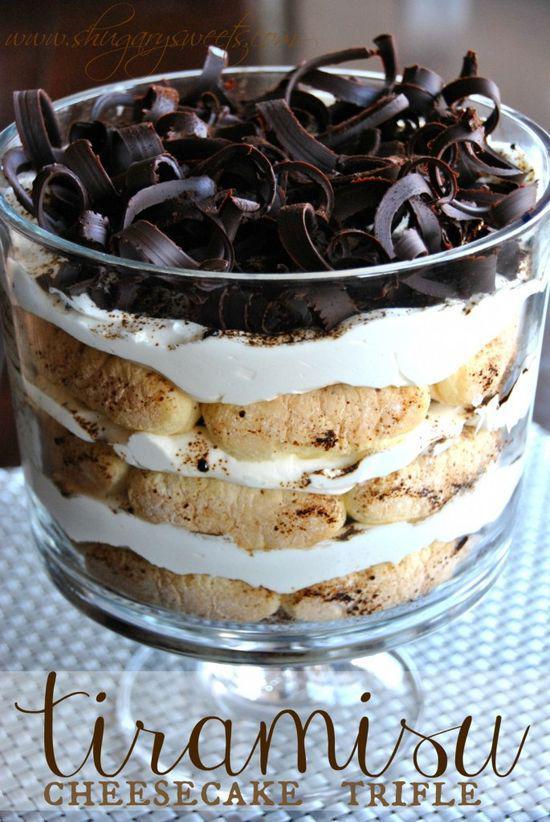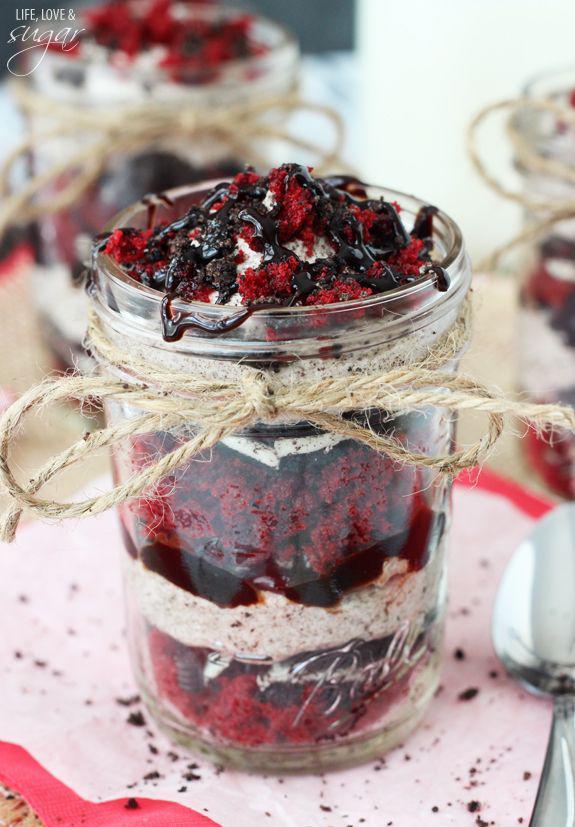The first image is the image on the left, the second image is the image on the right. Given the left and right images, does the statement "One image shows a dessert with no reddish-purple layer served in one footed glass, and the other shows a non-footed glass containing a reddish-purple layer." hold true? Answer yes or no. Yes. The first image is the image on the left, the second image is the image on the right. Assess this claim about the two images: "In one image, a large layered dessert with chocolate garnish is made in a clear glass footed bowl, while a second image shows one or more individual desserts made with red berries.". Correct or not? Answer yes or no. Yes. 